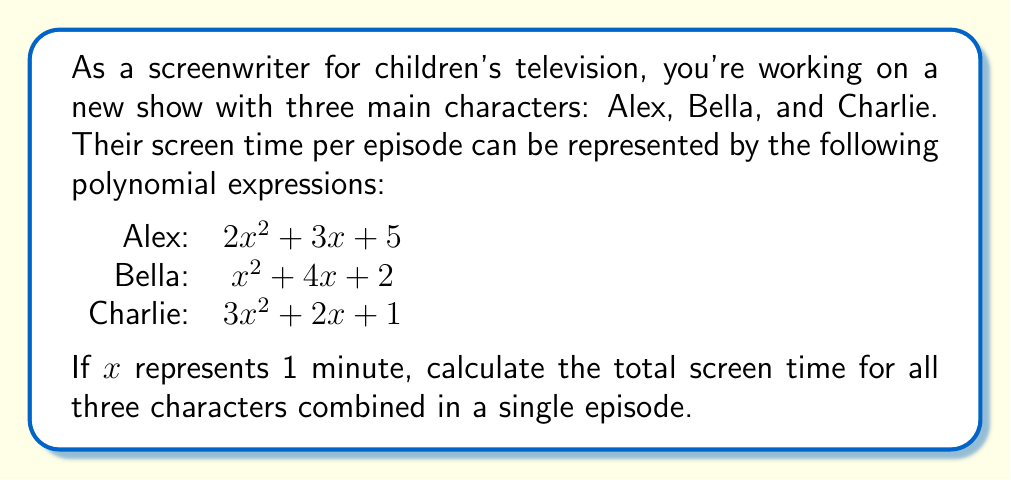Can you solve this math problem? To find the total screen time for all three characters, we need to add their polynomial expressions together. Let's break it down step-by-step:

1. Write out the polynomials for each character:
   Alex: $2x^2 + 3x + 5$
   Bella: $x^2 + 4x + 2$
   Charlie: $3x^2 + 2x + 1$

2. Add the polynomials by combining like terms:
   $$(2x^2 + 3x + 5) + (x^2 + 4x + 2) + (3x^2 + 2x + 1)$$

3. Group like terms:
   $$(2x^2 + x^2 + 3x^2) + (3x + 4x + 2x) + (5 + 2 + 1)$$

4. Simplify by adding the coefficients of like terms:
   $$6x^2 + 9x + 8$$

5. This resulting polynomial represents the total screen time for all three characters.

6. Since $x$ represents 1 minute, we can substitute $x = 1$ into our final polynomial:
   $$6(1)^2 + 9(1) + 8 = 6 + 9 + 8 = 23$$

Therefore, the total screen time for all three characters in a single episode is 23 minutes.
Answer: $23$ minutes 